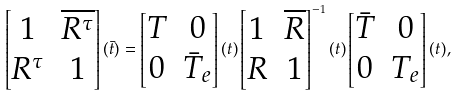Convert formula to latex. <formula><loc_0><loc_0><loc_500><loc_500>\begin{bmatrix} 1 & \overline { R ^ { \tau } } \\ R ^ { \tau } & 1 \end{bmatrix} ( \bar { t } ) = \begin{bmatrix} T & 0 \\ 0 & \bar { T } _ { e } \end{bmatrix} ( t ) \begin{bmatrix} 1 & \overline { R } \\ R & 1 \end{bmatrix} ^ { - 1 } ( t ) \begin{bmatrix} \bar { T } & 0 \\ 0 & T _ { e } \end{bmatrix} ( t ) ,</formula> 